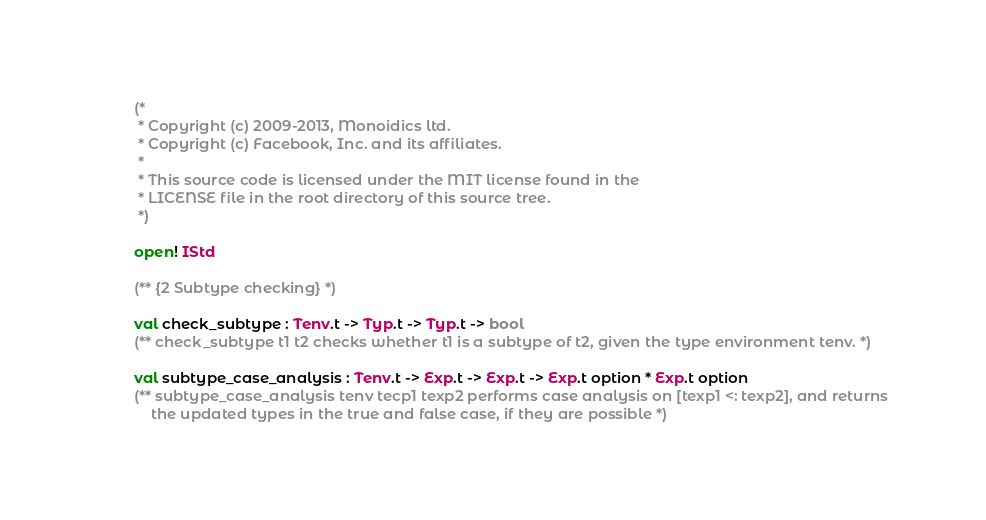<code> <loc_0><loc_0><loc_500><loc_500><_OCaml_>(*
 * Copyright (c) 2009-2013, Monoidics ltd.
 * Copyright (c) Facebook, Inc. and its affiliates.
 *
 * This source code is licensed under the MIT license found in the
 * LICENSE file in the root directory of this source tree.
 *)

open! IStd

(** {2 Subtype checking} *)

val check_subtype : Tenv.t -> Typ.t -> Typ.t -> bool
(** check_subtype t1 t2 checks whether t1 is a subtype of t2, given the type environment tenv. *)

val subtype_case_analysis : Tenv.t -> Exp.t -> Exp.t -> Exp.t option * Exp.t option
(** subtype_case_analysis tenv tecp1 texp2 performs case analysis on [texp1 <: texp2], and returns
    the updated types in the true and false case, if they are possible *)
</code> 